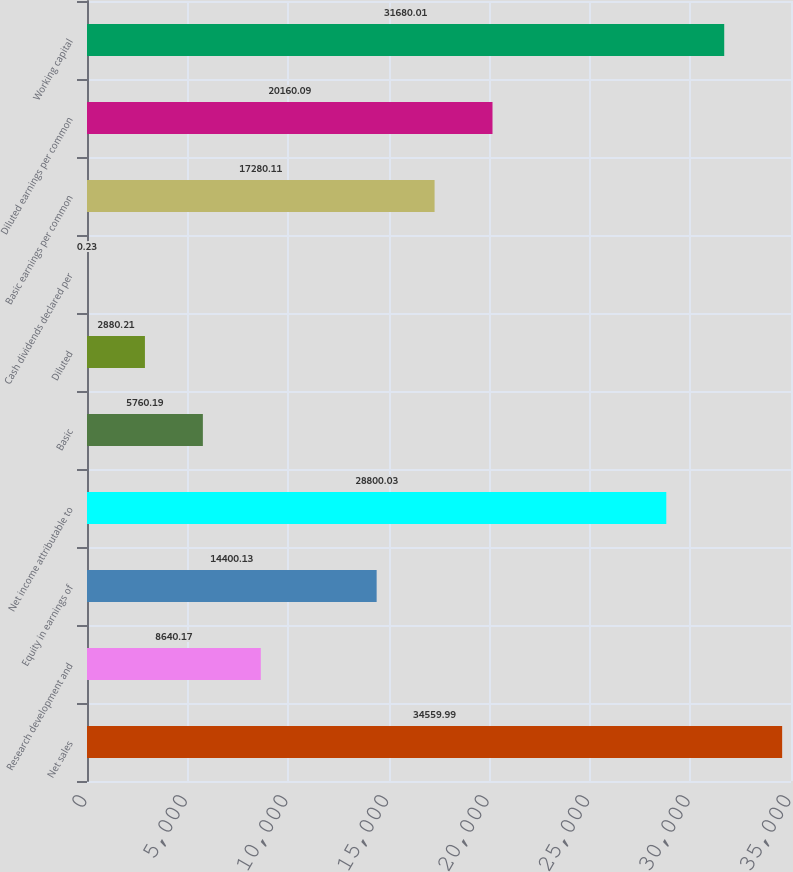<chart> <loc_0><loc_0><loc_500><loc_500><bar_chart><fcel>Net sales<fcel>Research development and<fcel>Equity in earnings of<fcel>Net income attributable to<fcel>Basic<fcel>Diluted<fcel>Cash dividends declared per<fcel>Basic earnings per common<fcel>Diluted earnings per common<fcel>Working capital<nl><fcel>34560<fcel>8640.17<fcel>14400.1<fcel>28800<fcel>5760.19<fcel>2880.21<fcel>0.23<fcel>17280.1<fcel>20160.1<fcel>31680<nl></chart> 